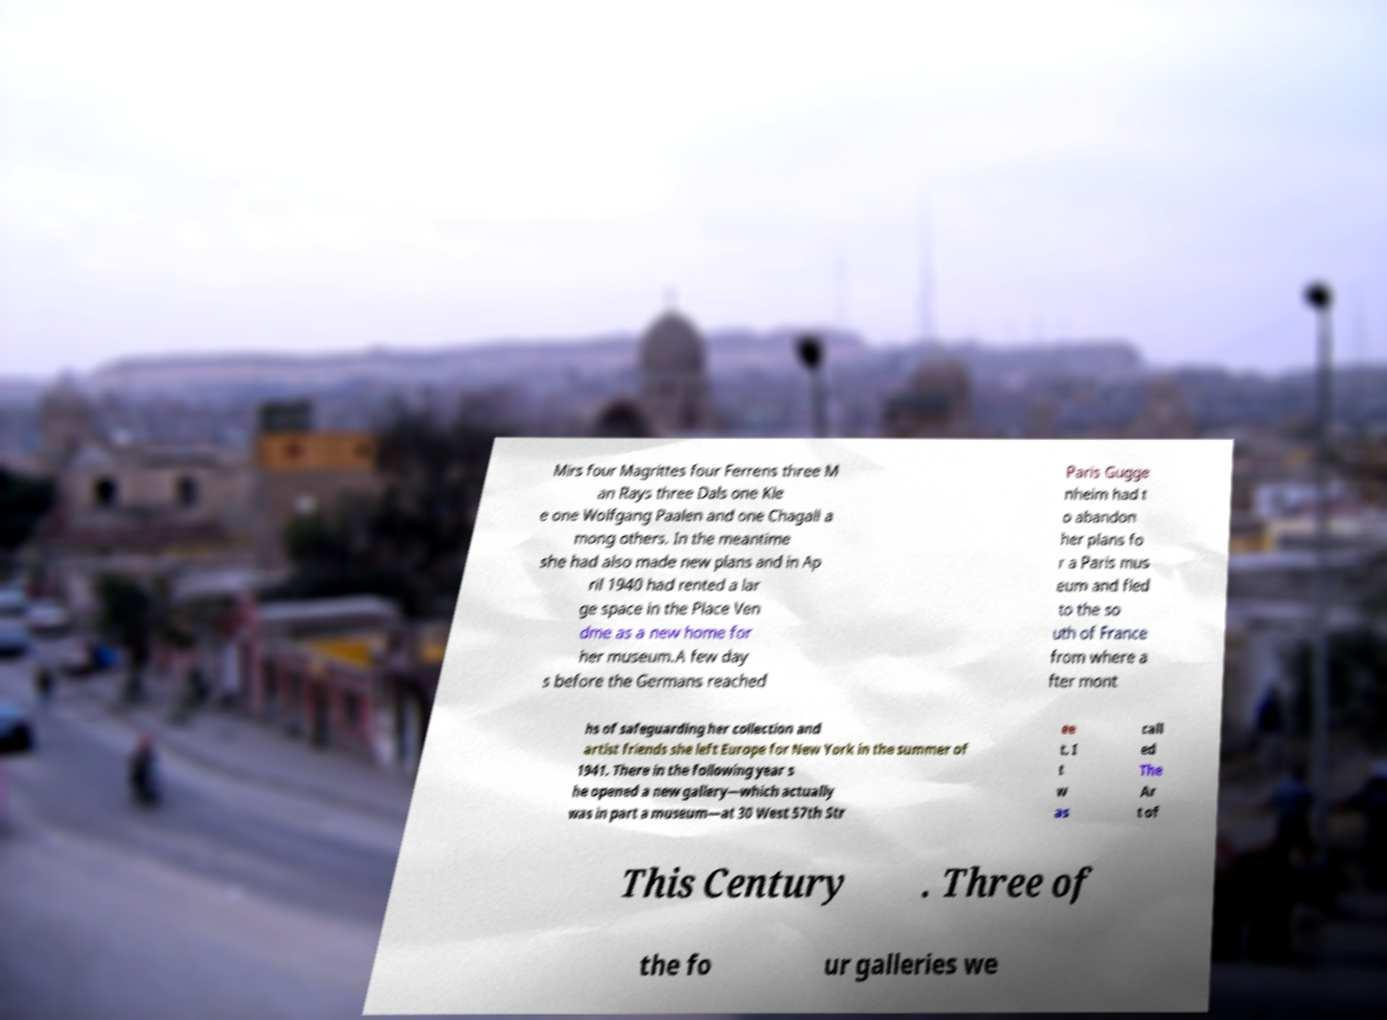Please identify and transcribe the text found in this image. Mirs four Magrittes four Ferrens three M an Rays three Dals one Kle e one Wolfgang Paalen and one Chagall a mong others. In the meantime she had also made new plans and in Ap ril 1940 had rented a lar ge space in the Place Ven dme as a new home for her museum.A few day s before the Germans reached Paris Gugge nheim had t o abandon her plans fo r a Paris mus eum and fled to the so uth of France from where a fter mont hs of safeguarding her collection and artist friends she left Europe for New York in the summer of 1941. There in the following year s he opened a new gallery—which actually was in part a museum—at 30 West 57th Str ee t. I t w as call ed The Ar t of This Century . Three of the fo ur galleries we 